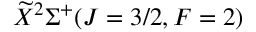Convert formula to latex. <formula><loc_0><loc_0><loc_500><loc_500>\widetilde { X } ^ { 2 } \Sigma ^ { + } ( J = 3 / 2 , F = 2 )</formula> 